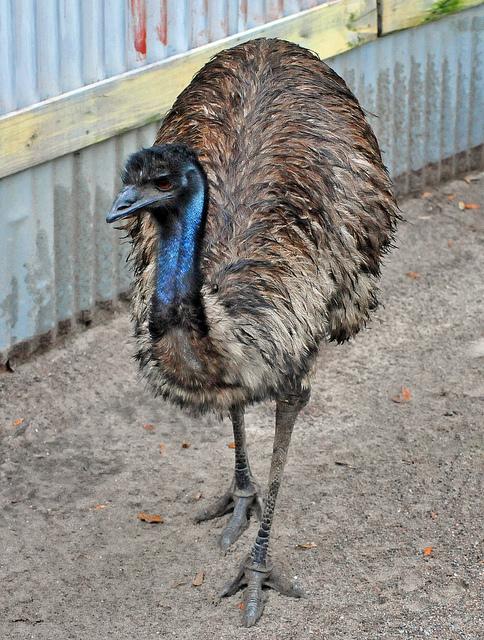What kind of animal is this?
Keep it brief. Peacock. Is the animal in the wild?
Keep it brief. No. What color are the animal's legs?
Be succinct. Gray. Does the birds have black spots on their heads?
Keep it brief. No. 